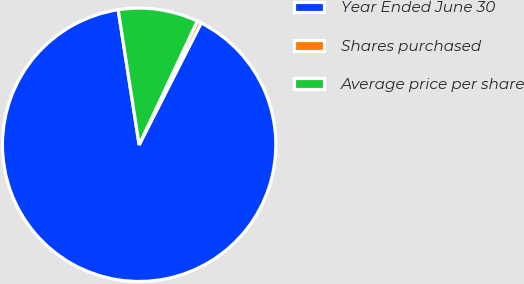Convert chart to OTSL. <chart><loc_0><loc_0><loc_500><loc_500><pie_chart><fcel>Year Ended June 30<fcel>Shares purchased<fcel>Average price per share<nl><fcel>90.06%<fcel>0.49%<fcel>9.45%<nl></chart> 